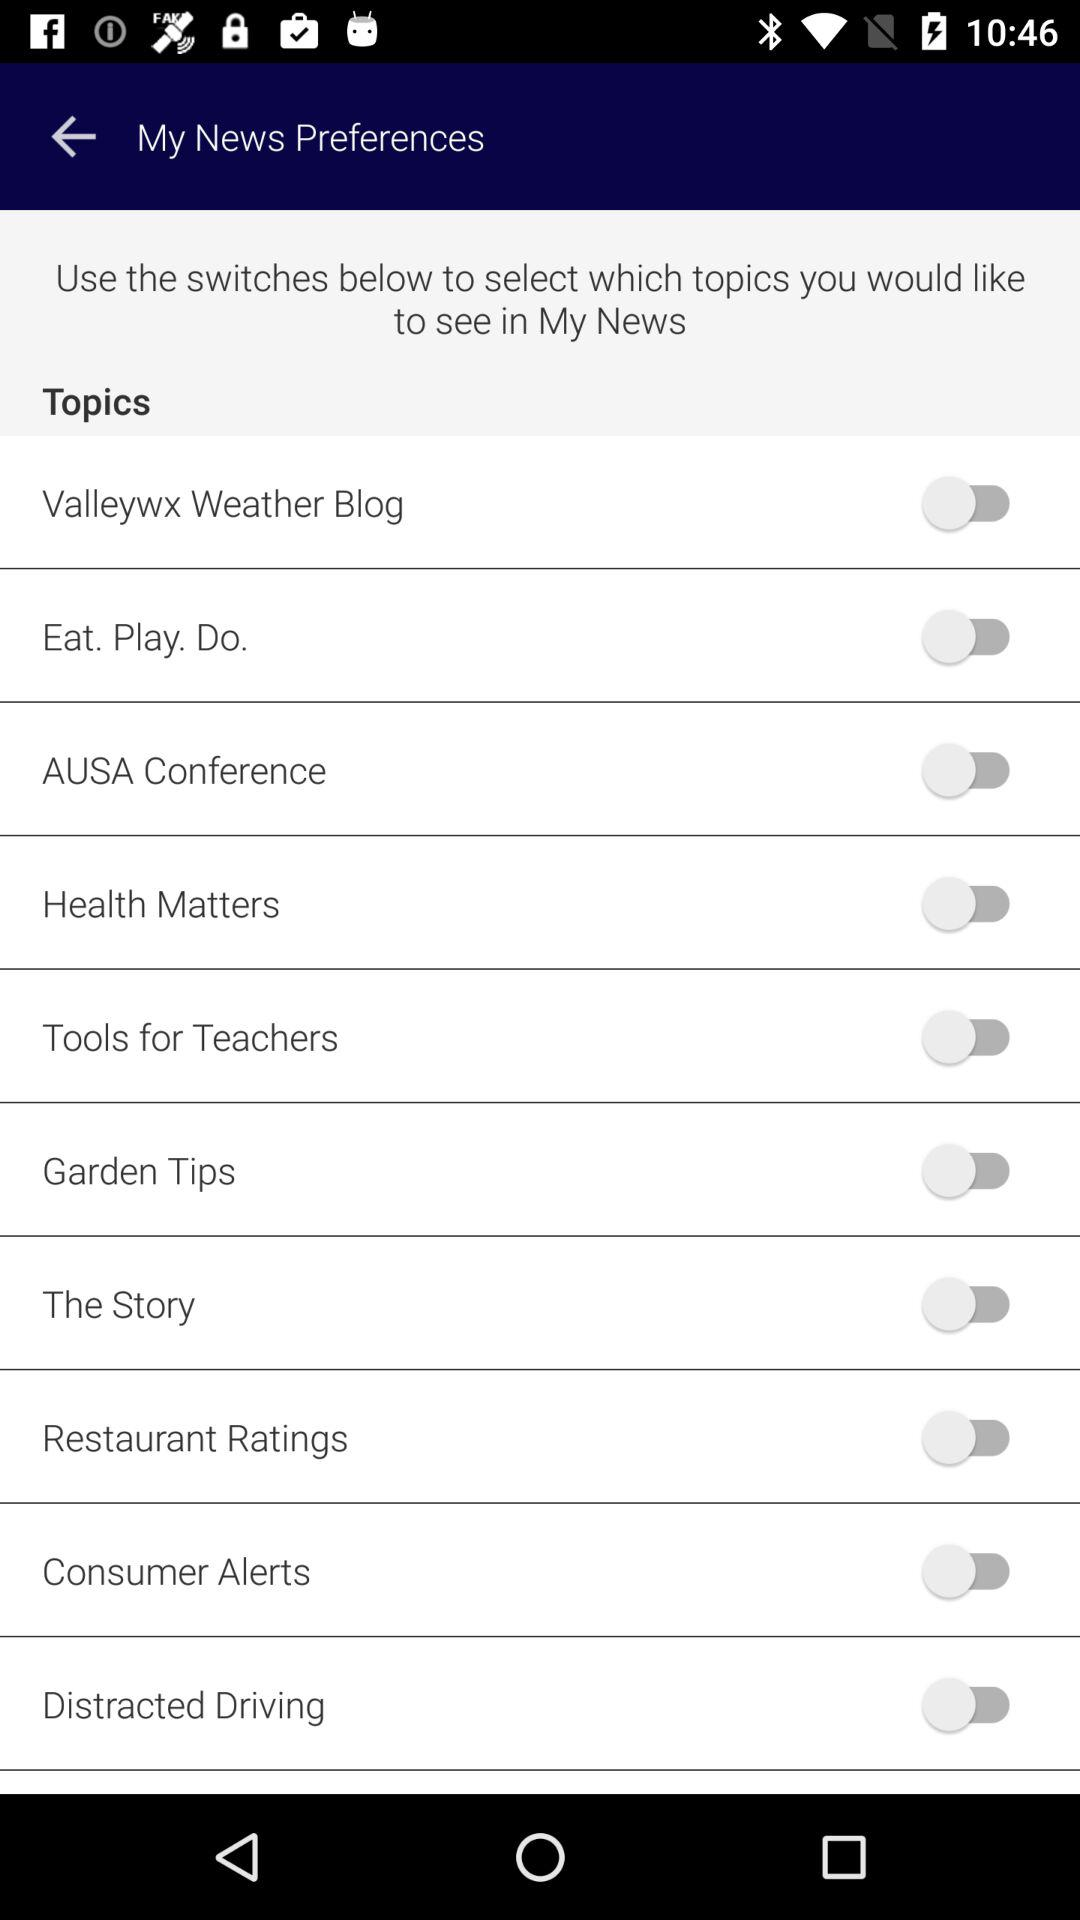What is the status of "Garden Tips"? The status of "Garden Tips" is "off". 